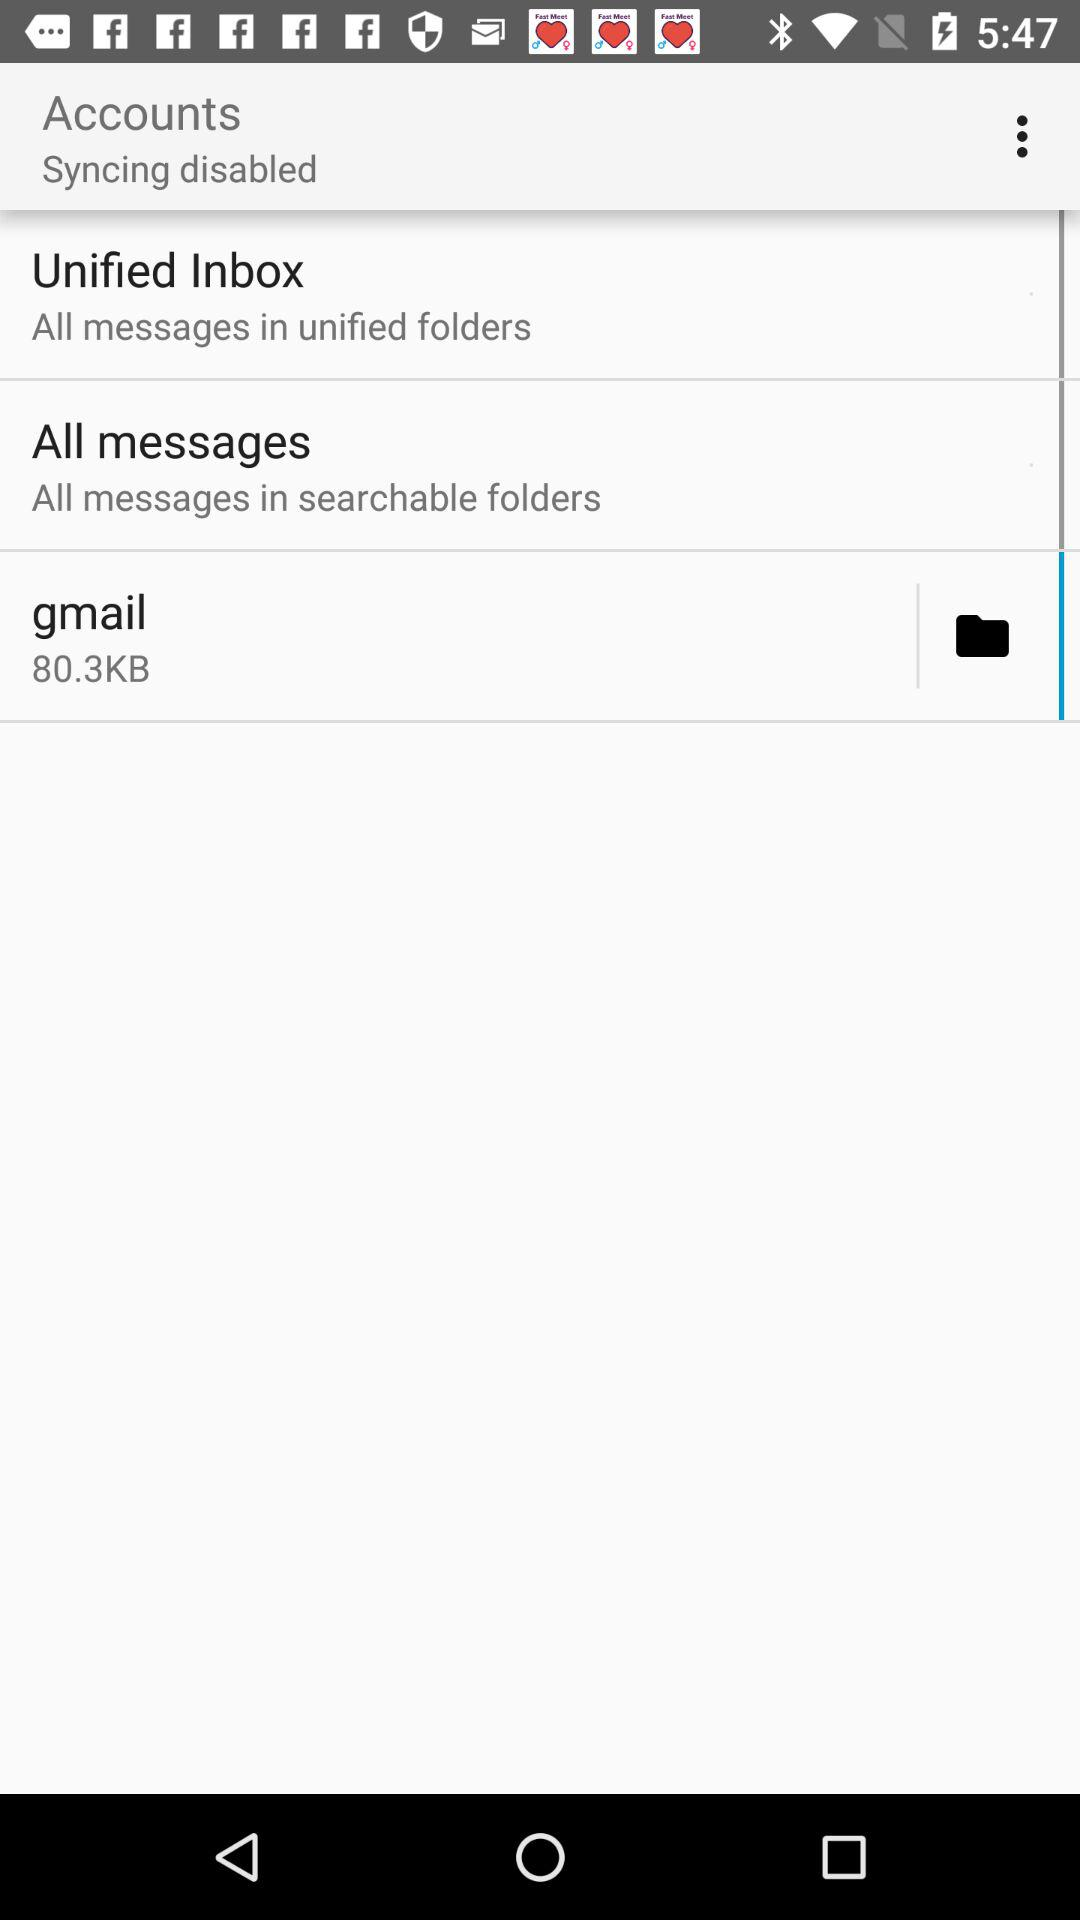What is the status of accounts syncing? The status of account syncing is disabled. 